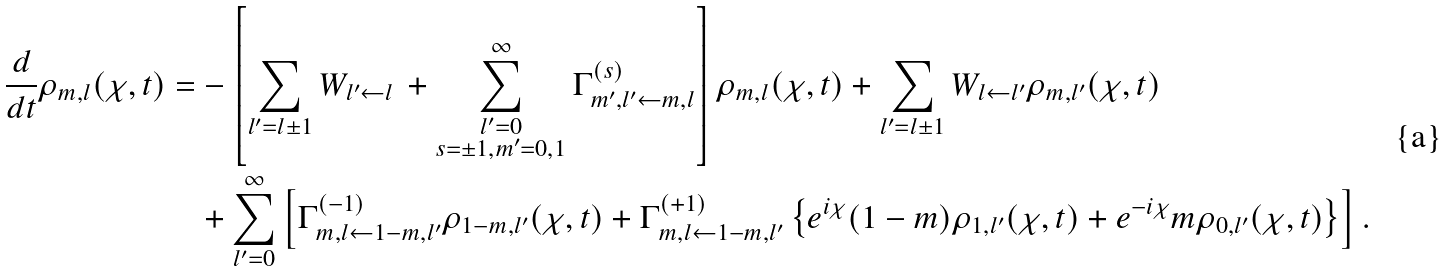<formula> <loc_0><loc_0><loc_500><loc_500>\frac { d } { d t } \rho _ { m , l } ( \chi , t ) = & - \left [ \sum _ { l ^ { \prime } = l \pm 1 } W _ { l ^ { \prime } \leftarrow l } \, + \sum ^ { \infty } _ { \substack { l ^ { \prime } = 0 \\ s = \pm 1 , m ^ { \prime } = 0 , 1 } } \Gamma _ { m ^ { \prime } , l ^ { \prime } \leftarrow m , l } ^ { ( s ) } \right ] \rho _ { m , l } ( \chi , t ) + \sum _ { l ^ { \prime } = l \pm 1 } W _ { l \leftarrow l ^ { \prime } } \rho _ { m , l ^ { \prime } } ( \chi , t ) \\ & + \sum _ { l ^ { \prime } = 0 } ^ { \infty } \left [ \Gamma _ { m , l \leftarrow 1 - m , l ^ { \prime } } ^ { ( - 1 ) } \rho _ { 1 - m , l ^ { \prime } } ( \chi , t ) + \Gamma _ { m , l \leftarrow 1 - m , l ^ { \prime } } ^ { ( + 1 ) } \left \{ e ^ { i \chi } ( 1 - m ) \rho _ { 1 , l ^ { \prime } } ( \chi , t ) + e ^ { - i \chi } m \rho _ { 0 , l ^ { \prime } } ( \chi , t ) \right \} \right ] .</formula> 